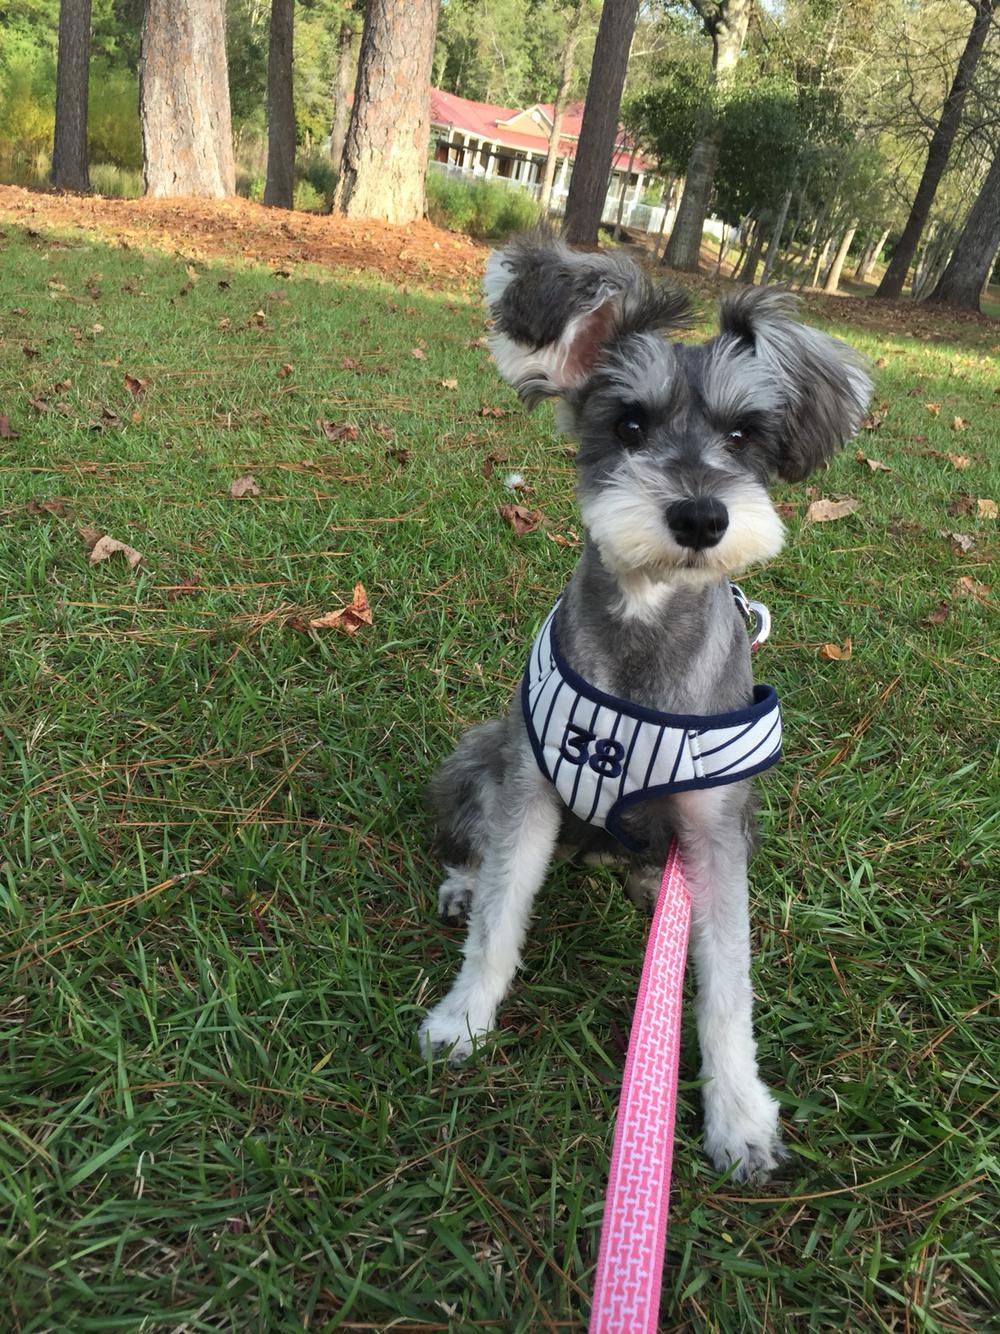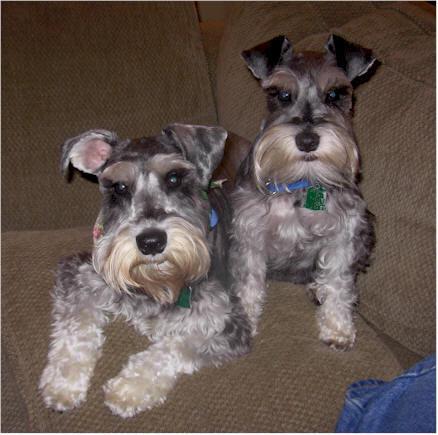The first image is the image on the left, the second image is the image on the right. Given the left and right images, does the statement "In one image, there are two Miniature Schnauzers sitting on some furniture." hold true? Answer yes or no. Yes. The first image is the image on the left, the second image is the image on the right. Assess this claim about the two images: "Some of the dogs are inside and the others are outside in the grass.". Correct or not? Answer yes or no. Yes. 